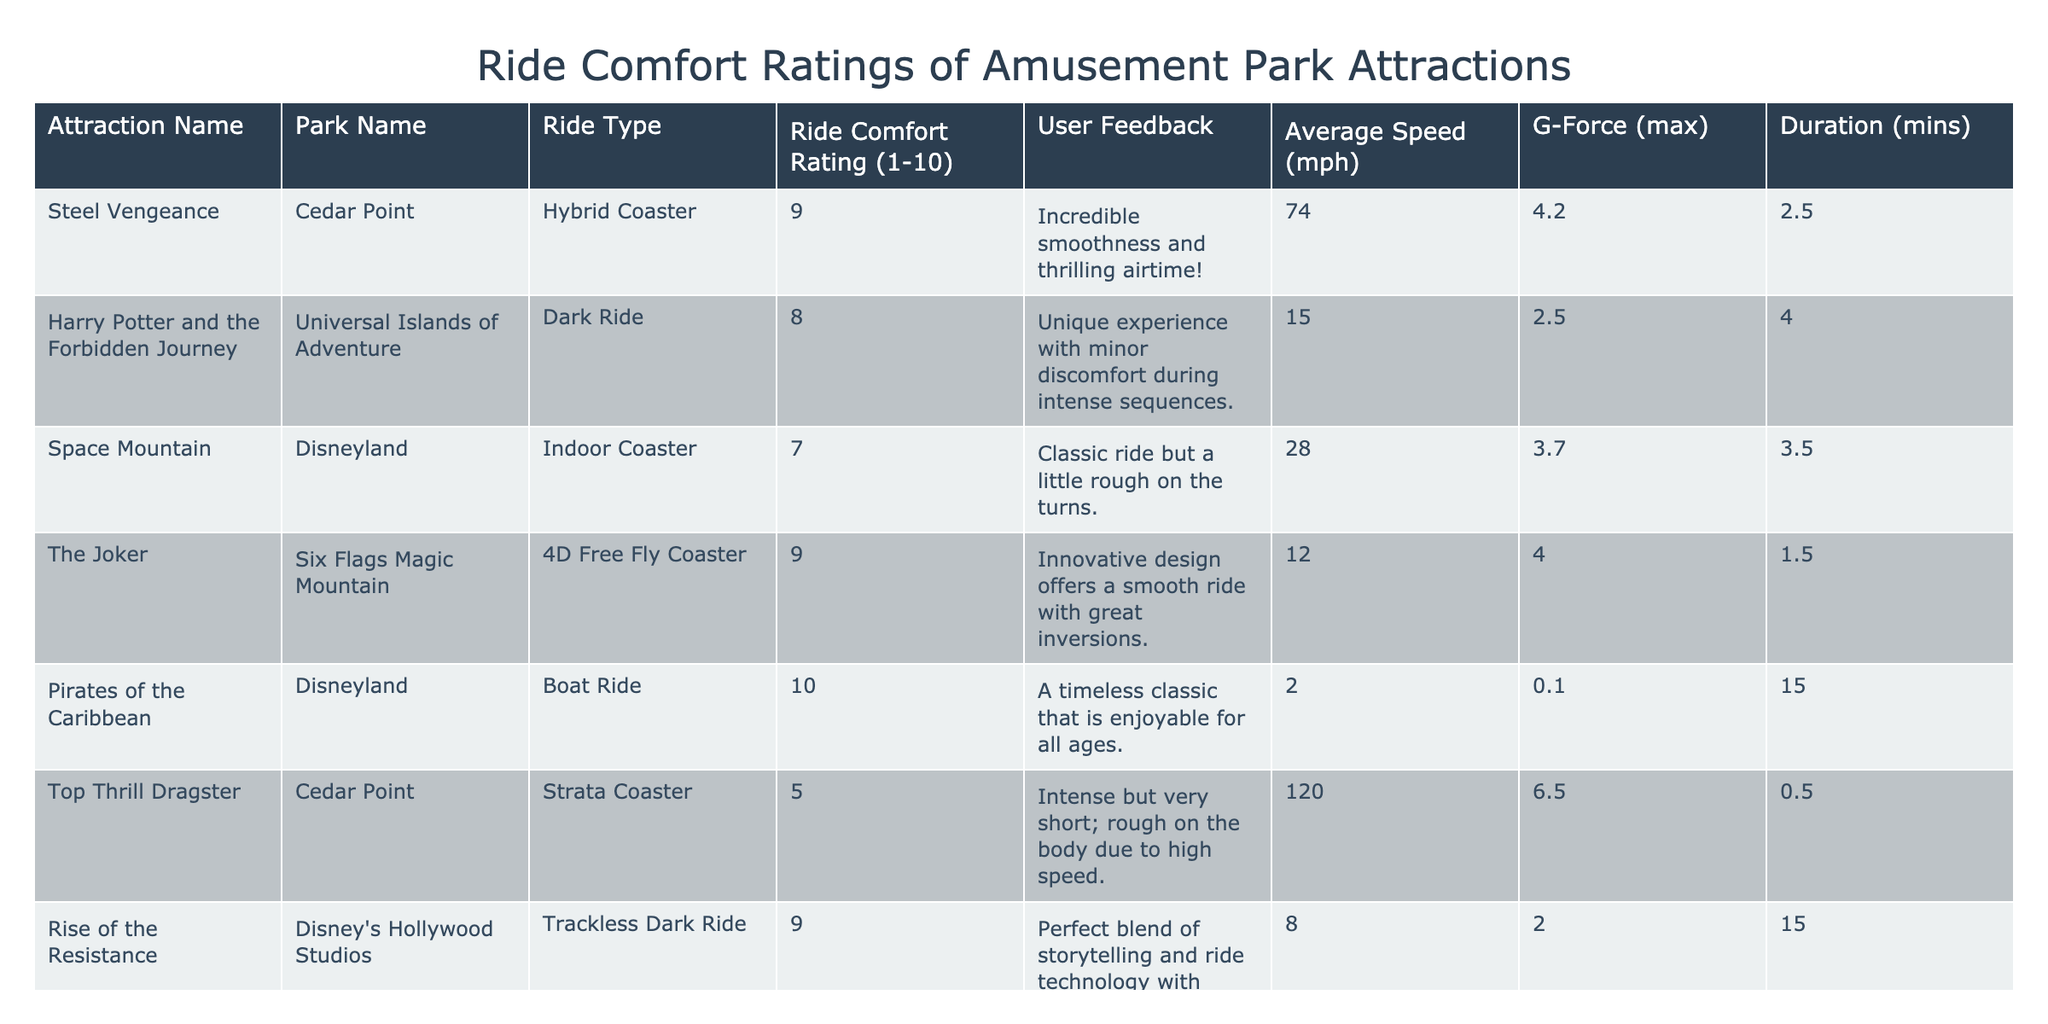What is the highest Ride Comfort Rating in the table? The Ride Comfort Ratings for the attractions range from 5 to 10. The highest rating listed is 10, corresponding to "Pirates of the Caribbean."
Answer: 10 Which attraction has the lowest Average Speed? Upon reviewing the Average Speed column, "Pirates of the Caribbean" has the lowest speed at 2 mph.
Answer: 2 mph How many attractions have a Ride Comfort Rating of 9 or above? The attractions with ratings of 9 or above are "Steel Vengeance," "The Joker," "Rise of the Resistance," and "Pirates of the Caribbean," making a total of 4 attractions.
Answer: 4 What is the average Ride Comfort Rating of the attractions listed? There are 7 attractions, and their ratings are 9, 8, 7, 9, 10, 5, and 9. Sum the ratings (9+8+7+9+10+5+9 = 57) and divide by 7 to get the average (57/7 ≈ 8.14).
Answer: Approximately 8.14 Does "Top Thrill Dragster" have a maximum G-Force greater than 5? The maximum G-Force for "Top Thrill Dragster" listed in the table is 6.5, which is indeed greater than 5.
Answer: Yes Which attraction has both the highest Ride Comfort Rating and the lowest Duration? "Pirates of the Caribbean" has the highest Ride Comfort Rating at 10 and the lowest Duration at 2 minutes.
Answer: "Pirates of the Caribbean" What is the average G-Force of all attractions with a Ride Comfort Rating lower than 8? The attractions with ratings lower than 8 are "Space Mountain" (3.5 G-Force) and "Top Thrill Dragster" (0.5 G-Force). The sum of their G-Forces is 3.5 + 5 = 6.5. The average is 6.5/2 = 3.25.
Answer: 3.25 Which attraction has the highest maximum G-Force among those rated 7 or higher? The attractions rated 7 or higher are "Steel Vengeance" (4.2 G-Force), "Harry Potter and the Forbidden Journey" (4), "The Joker" (1.5), "Rise of the Resistance" (15), and "Pirates of the Caribbean" (15). "Rise of the Resistance" has the highest maximum G-Force at 15.
Answer: 15 